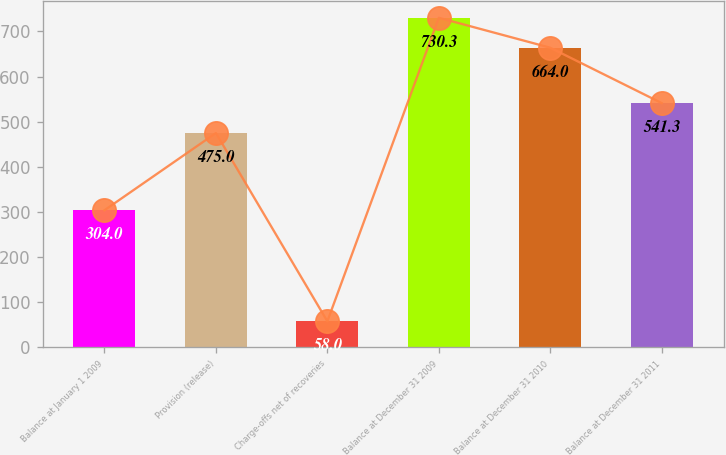Convert chart. <chart><loc_0><loc_0><loc_500><loc_500><bar_chart><fcel>Balance at January 1 2009<fcel>Provision (release)<fcel>Charge-offs net of recoveries<fcel>Balance at December 31 2009<fcel>Balance at December 31 2010<fcel>Balance at December 31 2011<nl><fcel>304<fcel>475<fcel>58<fcel>730.3<fcel>664<fcel>541.3<nl></chart> 